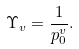Convert formula to latex. <formula><loc_0><loc_0><loc_500><loc_500>\Upsilon _ { v } = \frac { 1 } { p ^ { v } _ { 0 } } .</formula> 